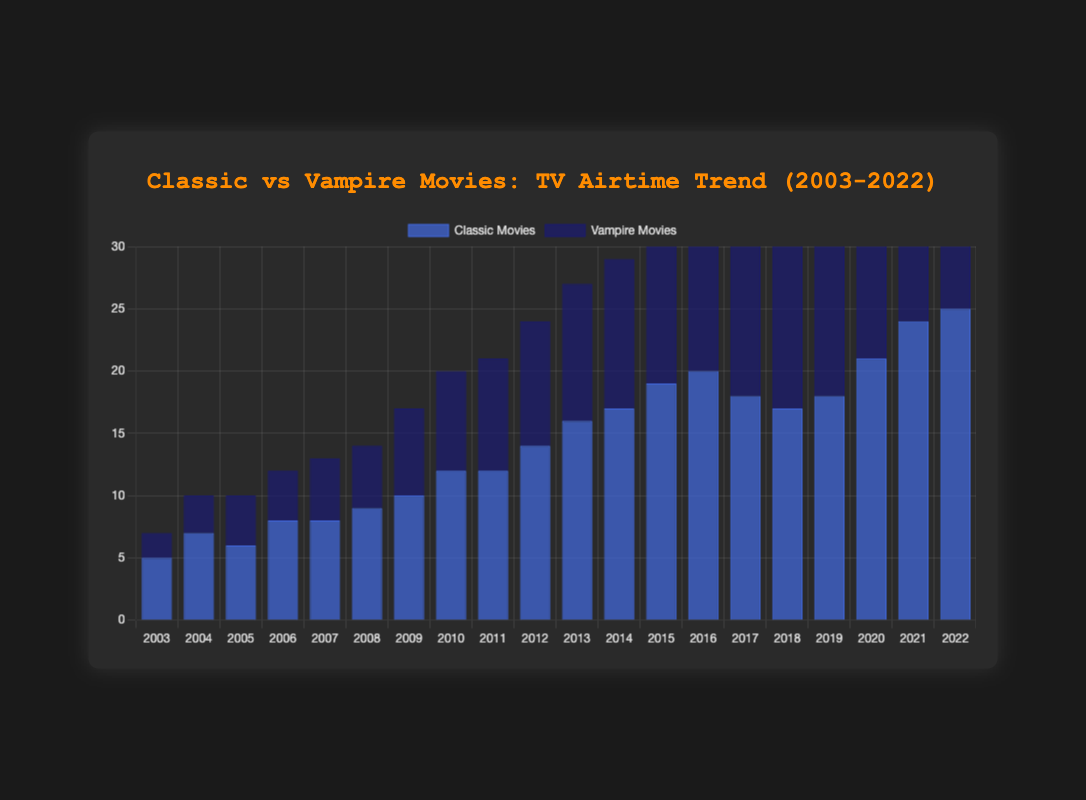What's the trend of classic movies airings over the given years? To determine the trend, look at the heights of the blue bars, which represent classic movies over the 20 years. The bars generally increase in height from 2003 to 2022, indicating a rising trend in airtime.
Answer: Rising What's the overall number of vampire movies aired in 2010 and 2015 combined? To find this, sum the frequency of vampire movies in 2010 and 2015. They were 8 and 13 respectively. Addition: 8 + 13 = 21.
Answer: 21 How does the airtime of vampire movies in 2022 compare to that of 2003? In 2022, the dark blue bar (vampire movies) is significantly higher than in 2003. Specifically, the frequency is 21 in 2022 and 2 in 2003. Thus, the airtime of vampire movies has increased over the years.
Answer: Increased What is the difference in airtime between classic and vampire movies in 2007? In 2007, the bar heights for classic and vampire movies were 8 and 5 respectively. Subtract the vampire frequency from the classic frequency: 8 - 5 = 3.
Answer: 3 What was the average frequency of classic movies aired in the first 10 years? To find the average, sum the frequencies of classic movies from 2003 to 2012 and divide by the number of years. (5+7+6+8+8+9+10+12+12+14) = 91. Average: 91/10 = 9.1
Answer: 9.1 In which year did the airings of vampire movies surpass 10 for the first time? Look for the first year where the height of the dark blue bar (vampire movies) exceeds 10. This occurs in 2013.
Answer: 2013 What was the total number of airings for both classic and vampire movies in 2019? Sum the frequencies for both movie types in 2019. Classic movies are 18 and vampire movies are 16. Addition: 18 + 16 = 34.
Answer: 34 In which year did classic movies have exactly double the frequency of vampire movies? Find a year where the frequency of classic movies is twice that of vampire movies. In 2016, classic movies had a frequency of 20 and vampire movies had 10, which fits the criteria.
Answer: 2016 How many years did vampire movies have fewer airings than classic movies? Compare the heights of blue and dark blue bars year by year. Classic movies had higher frequencies in the following years: 2003, 2004, 2005, 2006, 2007, 2008, 2009, 2010, 2011, 2012, 2013, 2014, 2015, 2016, and 2017. The total number of years is 15.
Answer: 15 